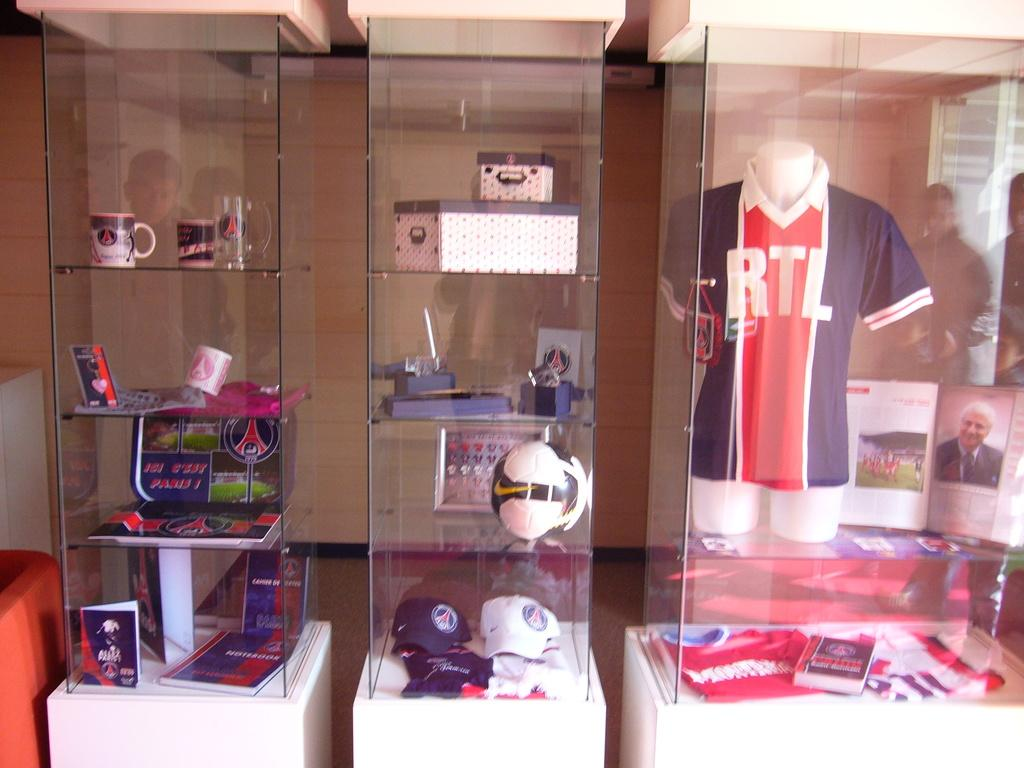<image>
Write a terse but informative summary of the picture. RTL shirt and different kinds of items that are presented on a Glass Cabinet Shelf. 